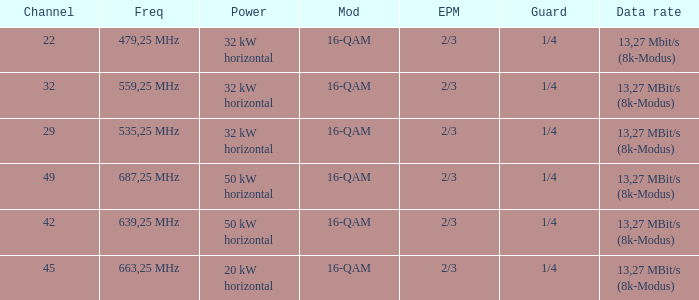On channel 32, when the power is 32 kW horizontal, what is the frequency? 559,25 MHz. 